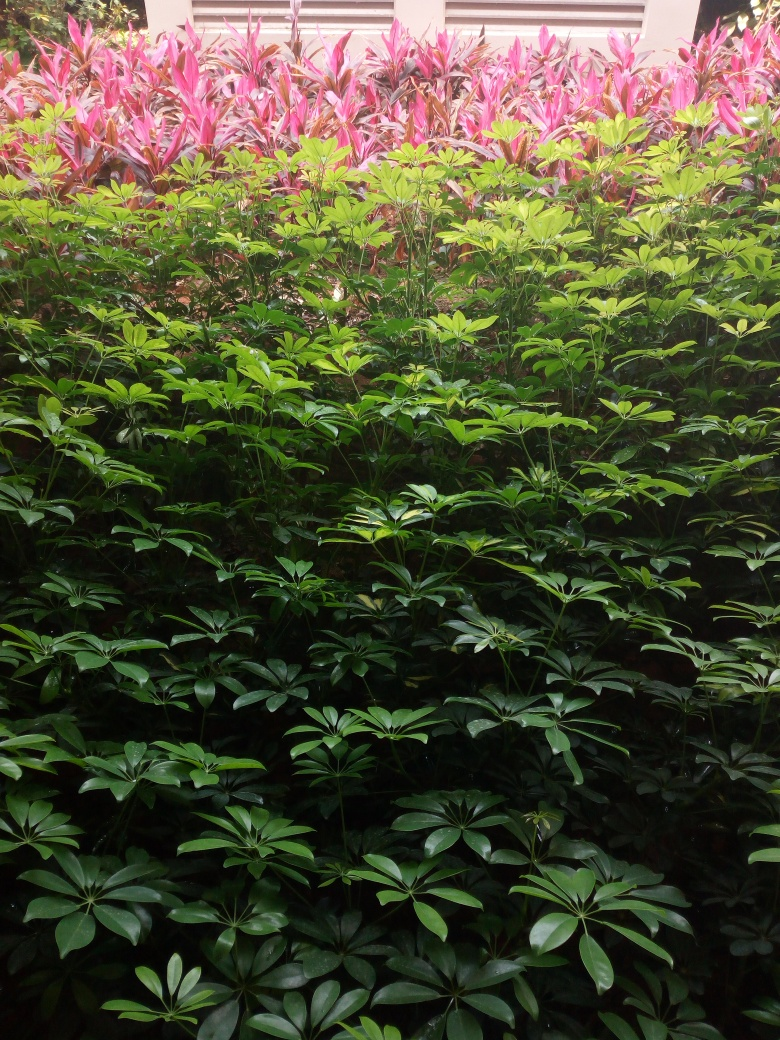Are the texture details unclear? The textures in the image are quite clear and distinct. It's possible to discern the different shades of green and the intricate vein patterns on the leaves, as well as the vibrant pink and red hues of the plants in the background. 